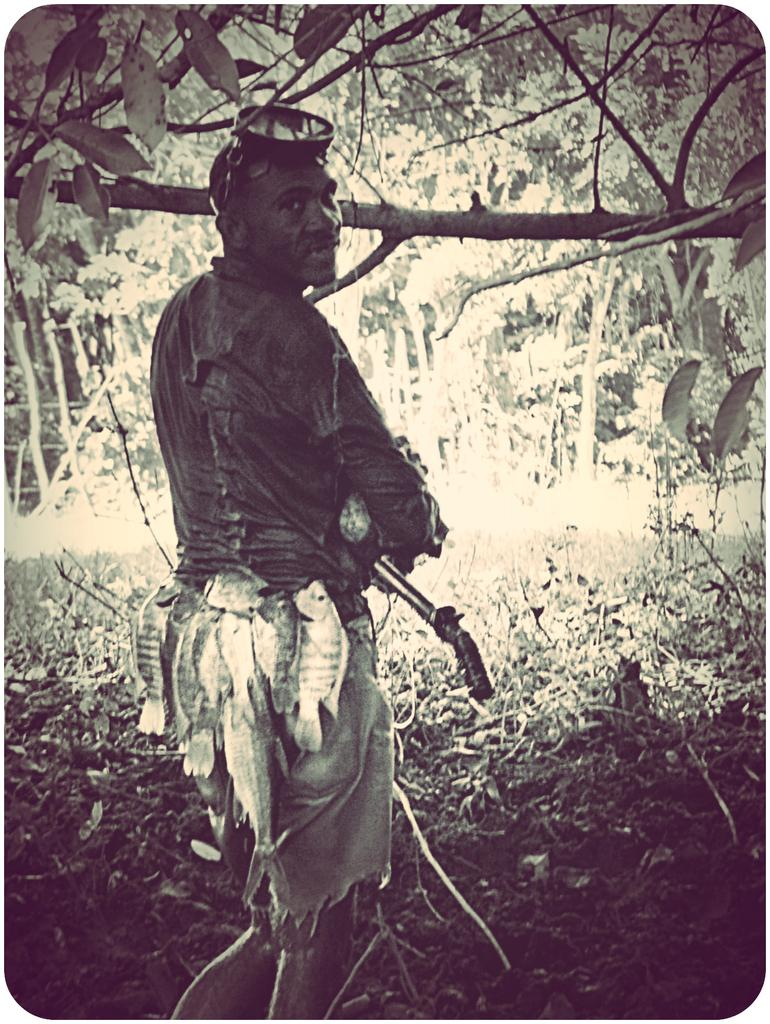What is the color scheme of the image? The image is black and white. Who or what is the main subject in the image? There is a man in the image. What can be seen in the background of the image? There are trees in the background of the image. What type of prison can be seen in the background of the image? There is no prison present in the image; it features a man and trees in the background. Can you tell me how many buns are on the man's head in the image? There are no buns present on the man's head in the image. 